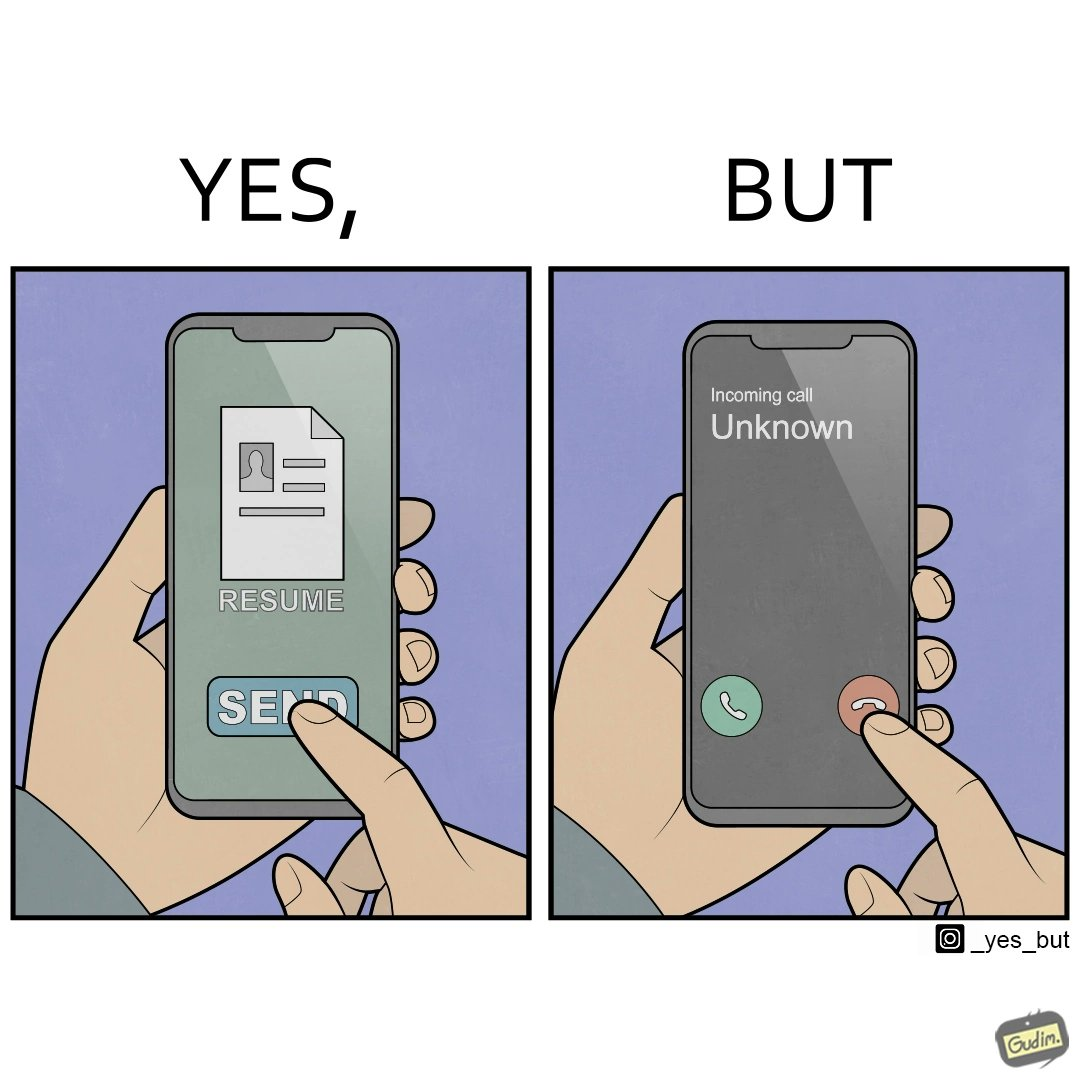Compare the left and right sides of this image. In the left part of the image: a mobile screen with resume asking the user whether to send button In the right part of the image: a mobile screen with an incoming call from unknown which the person might be rejecting 